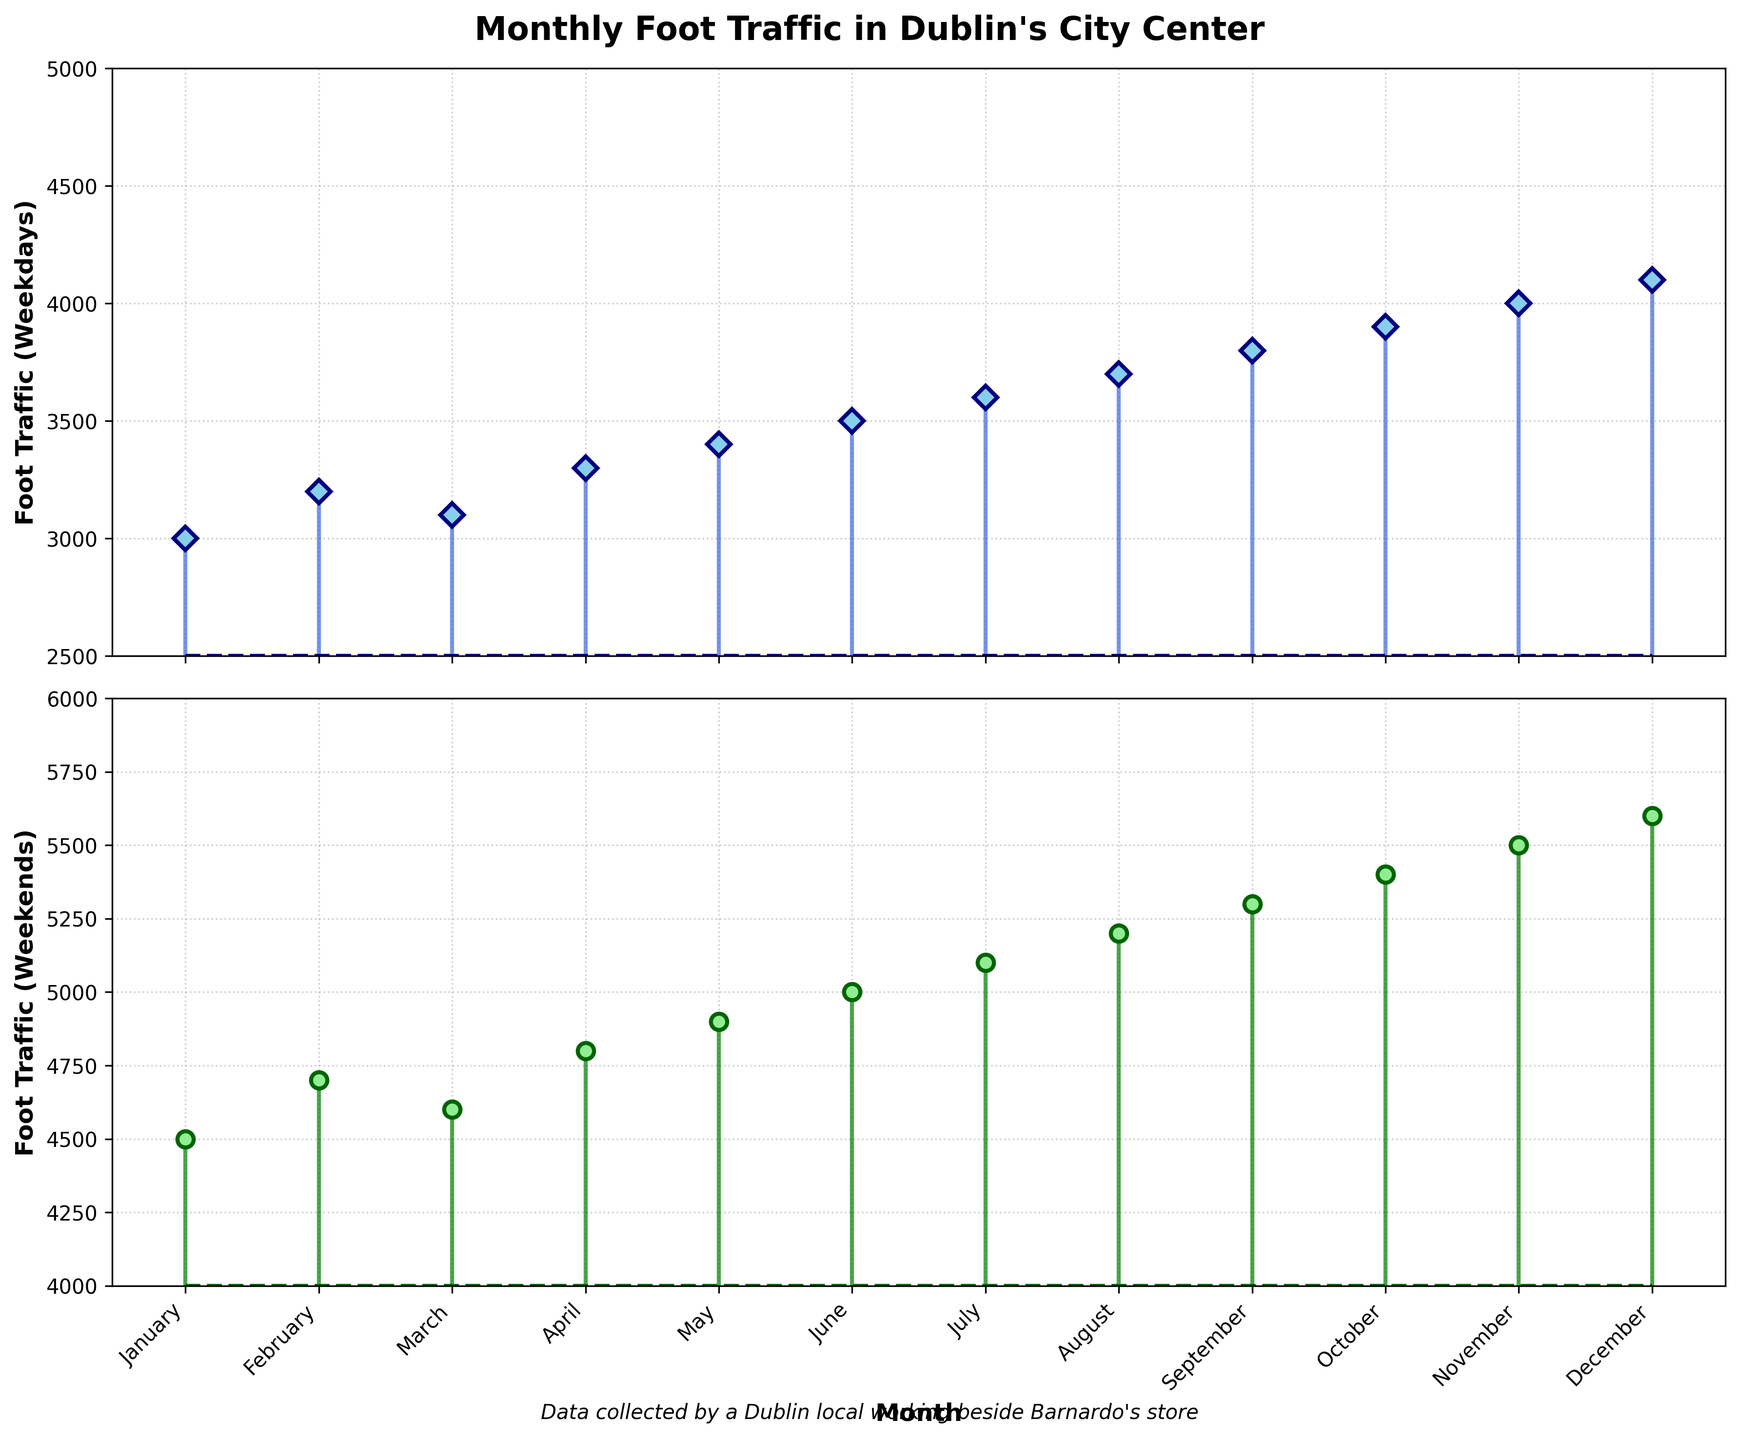What is the title of the plot? The title of the plot is the largest text at the top center of the figure. It provides an overview of what the plot represents. The title reads "Monthly Foot Traffic in Dublin's City Center".
Answer: Monthly Foot Traffic in Dublin's City Center What are the two subplots displaying? The two subplots are labeled. The first subplot is labeled "Foot Traffic (Weekdays)", indicating it shows foot traffic on weekdays. The second subplot is labeled "Foot Traffic (Weekends)", indicating it displays foot traffic on weekends.
Answer: Weekday and Weekend Foot Traffic What is the overall trend in foot traffic from January to December on weekdays? Observing the markers on the first subplot, the weekday foot traffic shows a gradual increase from January (around 3000) to December (around 4100). The upward trend signifies that foot traffic increases as the year progresses.
Answer: Gradual Increase Which month has the highest weekday foot traffic? Look at the first subplot and identify the highest marker. The highest weekday foot traffic is seen in December, as indicated by the marker placed at approximately 4100.
Answer: December What is the minimum foot traffic on weekends? Examining the second subplot, the lowest marker is observed in January or February, which is around 4500. This is the minimum traffic value for weekends.
Answer: 4500 In which month is the difference between weekend and weekday foot traffic the greatest? To find the month with the greatest difference, calculate the difference between weekend and weekday traffic for each month from both subplots. The largest difference appears to be in December, where the values are around 4100 (weekday) and 5600 (weekend), resulting in a difference of 1500.
Answer: December On which street is the foot traffic measured for the month of March for weekdays? Refer to the data provided for March and the weekday category. According to the data, the measurement is taken on Grafton Street.
Answer: Grafton Street Compare the foot traffic on Henry Street during the weekends in May and August. Which is higher? Locate the markers on the second subplot for May and August on Henry Street. May shows a foot traffic of 4900, while August shows a foot traffic of 5200. Comparing these values, August has higher foot traffic.
Answer: August What is the combined foot traffic for weekends in June and July? Sum up the weekend foot traffic values for June and July from the second subplot. June has a value of 5000, and July has a value of 5100. The combined foot traffic is 5000 + 5100 = 10100.
Answer: 10100 